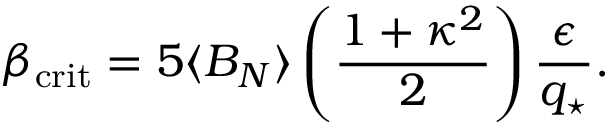Convert formula to latex. <formula><loc_0><loc_0><loc_500><loc_500>\beta _ { c r i t } = 5 \langle B _ { N } \rangle \left ( { \frac { 1 + \kappa ^ { 2 } } { 2 } } \right ) { \frac { \epsilon } { q _ { ^ { * } } } } .</formula> 